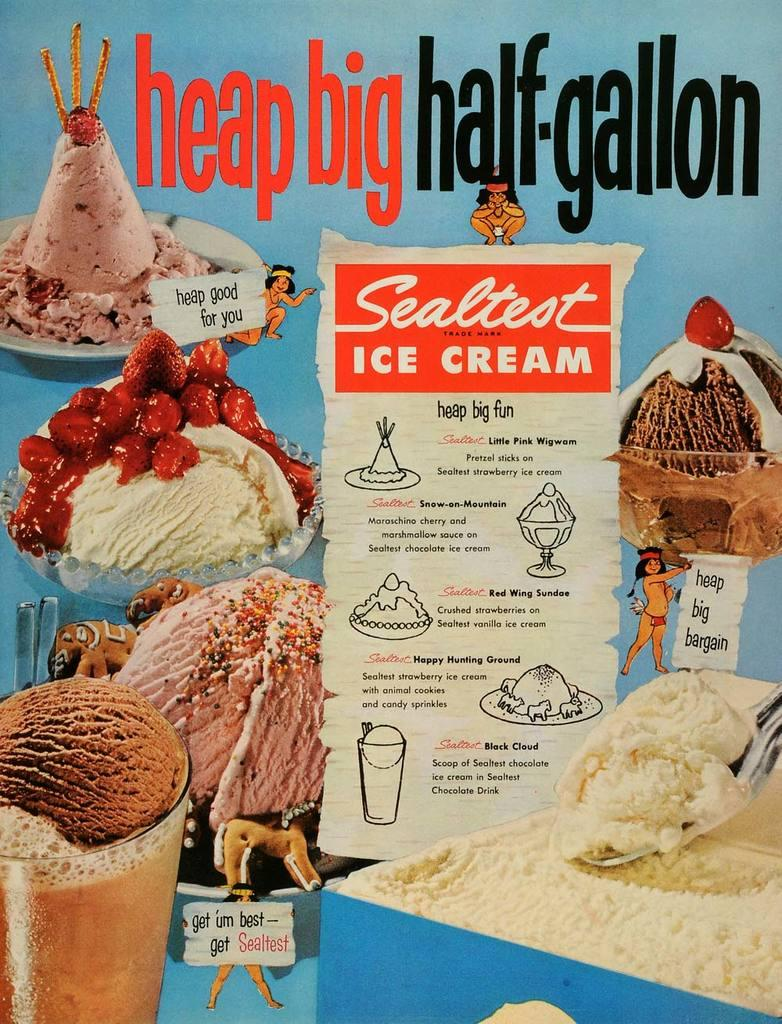What is present in the image related to advertising or information? There is a poster in the image. What is the main subject of the poster? The poster contains different flavors of ice creams. Are there any additional details about the ice cream flavors on the poster? Yes, the poster includes descriptions of the ice cream flavors. What type of zinc is used to create the alarm on the poster? There is no zinc or alarm present on the poster; it features different flavors of ice creams and their descriptions. 